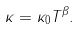Convert formula to latex. <formula><loc_0><loc_0><loc_500><loc_500>\kappa = \kappa _ { 0 } T ^ { \beta } .</formula> 